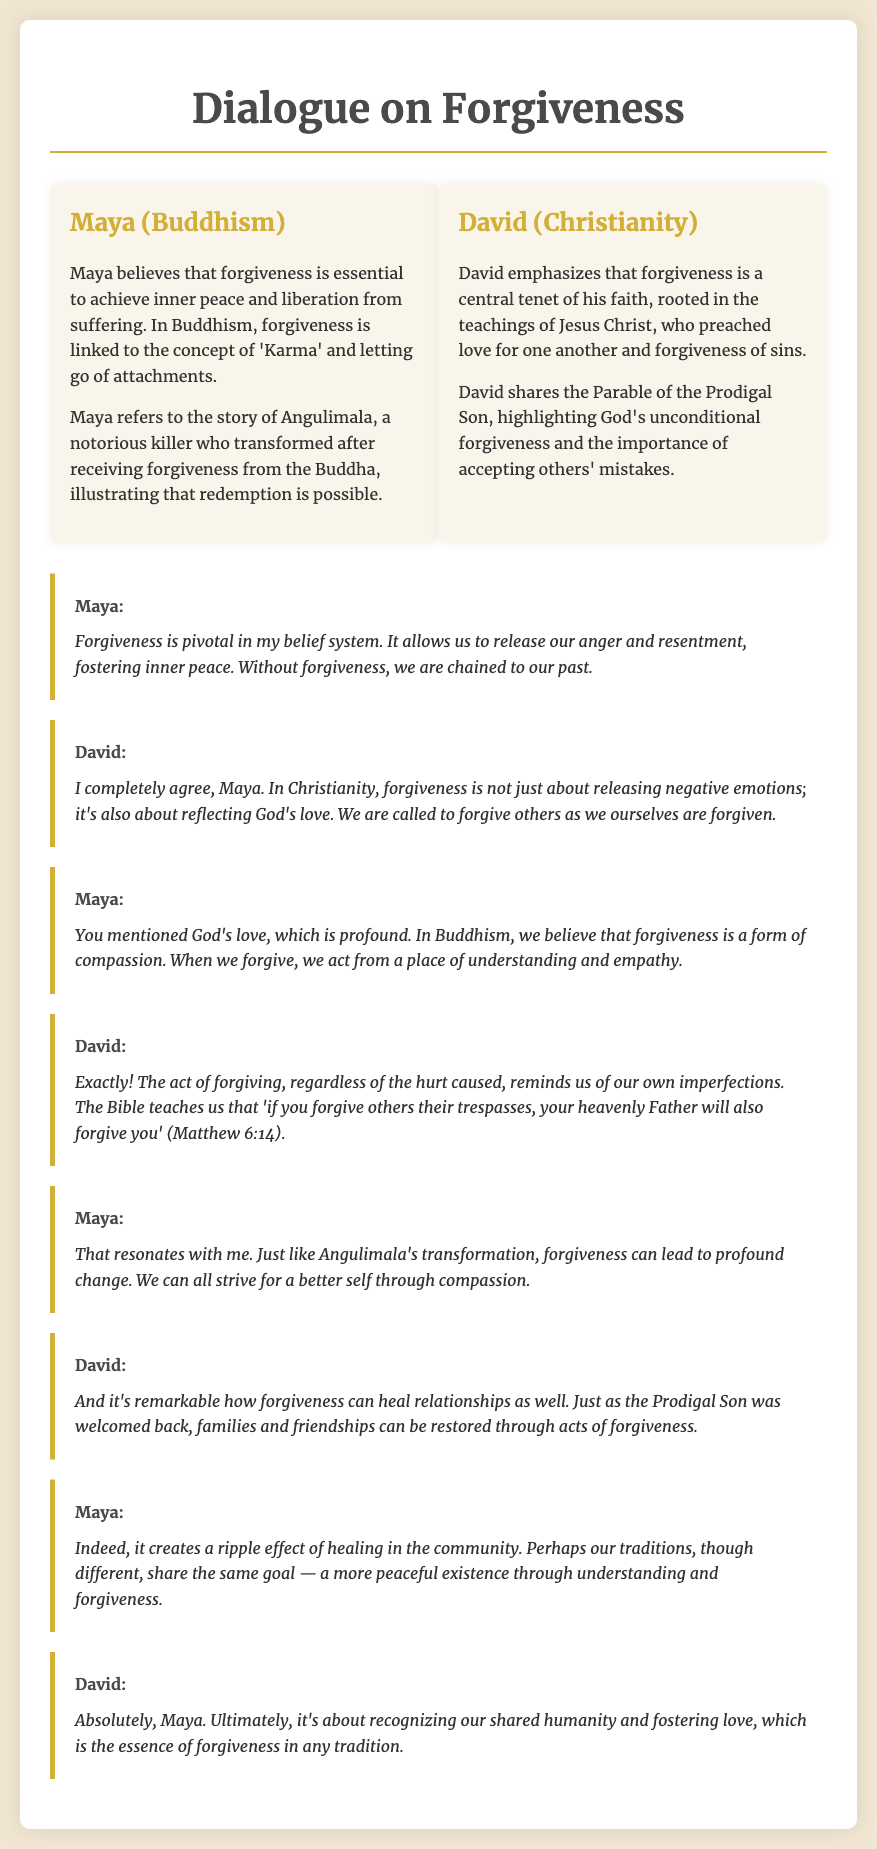What is the name of the character representing Buddhism? The character representing Buddhism in the document is named Maya.
Answer: Maya What story does Maya refer to in her dialogue? Maya refers to the story of Angulimala to illustrate the concept of forgiveness.
Answer: Angulimala Which parable does David share in his dialogue? David shares the Parable of the Prodigal Son to highlight God's unconditional forgiveness.
Answer: Parable of the Prodigal Son What is the connection between forgiveness and compassion in Buddhism according to Maya? Maya states that forgiveness is a form of compassion linked to understanding and empathy.
Answer: Compassion What biblical reference does David make about forgiveness? David mentions that if you forgive others their trespasses, your heavenly Father will also forgive you.
Answer: Matthew 6:14 What is a common goal that both characters identify in their discussion? Both characters believe that understanding and forgiveness lead to a more peaceful existence.
Answer: A more peaceful existence What effect does Maya believe forgiveness can have on the community? Maya believes that forgiveness can create a ripple effect of healing in the community.
Answer: Ripple effect of healing What does David emphasize as essential in his faith regarding forgiveness? David emphasizes that forgiveness is a central tenet in Christianity.
Answer: Central tenet 